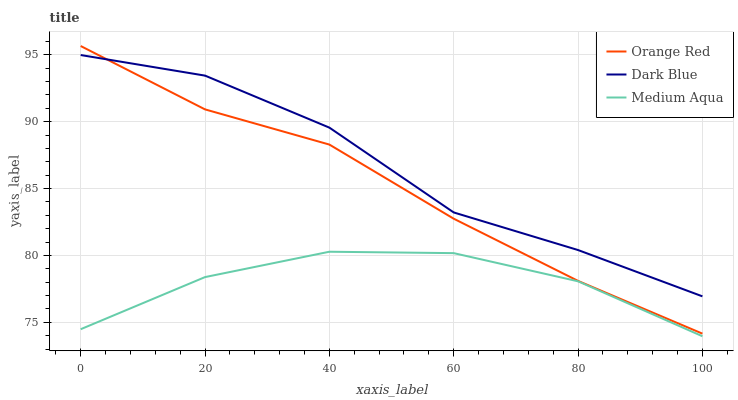Does Medium Aqua have the minimum area under the curve?
Answer yes or no. Yes. Does Dark Blue have the maximum area under the curve?
Answer yes or no. Yes. Does Orange Red have the minimum area under the curve?
Answer yes or no. No. Does Orange Red have the maximum area under the curve?
Answer yes or no. No. Is Orange Red the smoothest?
Answer yes or no. Yes. Is Dark Blue the roughest?
Answer yes or no. Yes. Is Medium Aqua the smoothest?
Answer yes or no. No. Is Medium Aqua the roughest?
Answer yes or no. No. Does Medium Aqua have the lowest value?
Answer yes or no. Yes. Does Orange Red have the lowest value?
Answer yes or no. No. Does Orange Red have the highest value?
Answer yes or no. Yes. Does Medium Aqua have the highest value?
Answer yes or no. No. Is Medium Aqua less than Orange Red?
Answer yes or no. Yes. Is Orange Red greater than Medium Aqua?
Answer yes or no. Yes. Does Orange Red intersect Dark Blue?
Answer yes or no. Yes. Is Orange Red less than Dark Blue?
Answer yes or no. No. Is Orange Red greater than Dark Blue?
Answer yes or no. No. Does Medium Aqua intersect Orange Red?
Answer yes or no. No. 